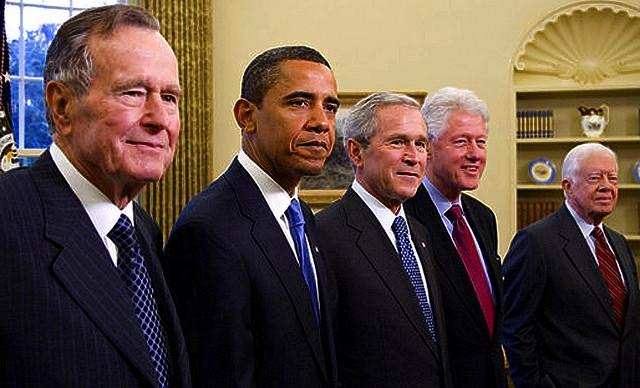Is the president of the United States in the picture?
Short answer required. Yes. How many men are wearing blue ties?
Quick response, please. 3. Who were these men?
Keep it brief. Presidents. 